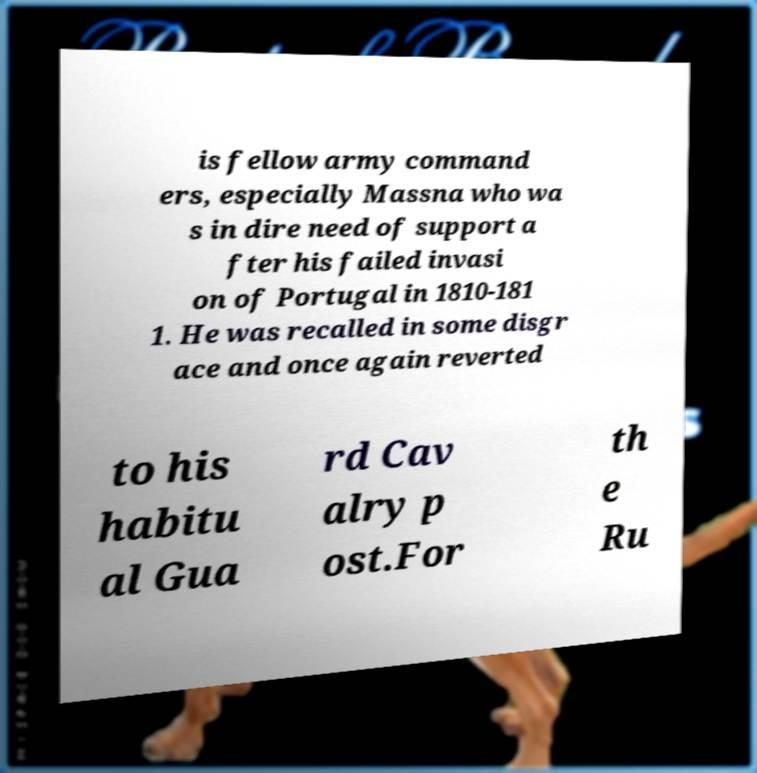Could you extract and type out the text from this image? is fellow army command ers, especially Massna who wa s in dire need of support a fter his failed invasi on of Portugal in 1810-181 1. He was recalled in some disgr ace and once again reverted to his habitu al Gua rd Cav alry p ost.For th e Ru 